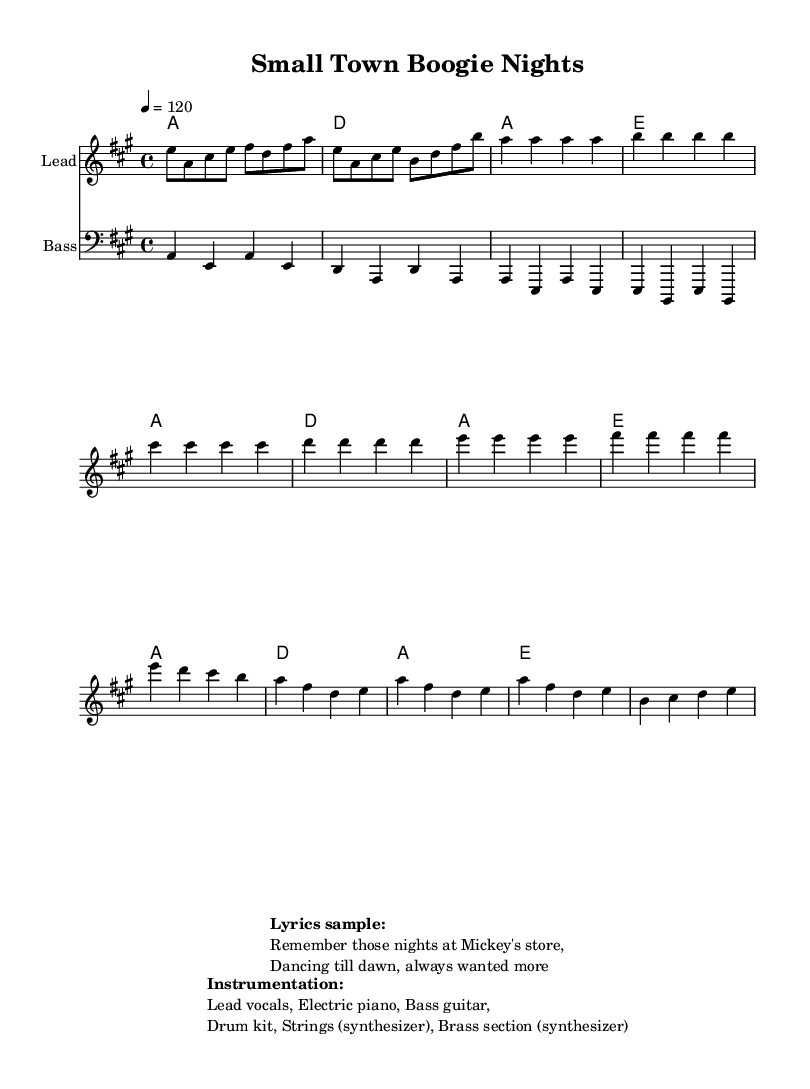What is the key signature of this music? The key signature indicated on the sheet music is A major, which has three sharps (F#, C#, and G#). This is visually confirmed by looking at the key signature placement at the beginning of the staff.
Answer: A major What is the time signature of the piece? The time signature shown in the sheet music is 4/4, meaning there are four beats in each measure and each quarter note gets one beat. This can be identified by the time signature notation at the beginning of the score.
Answer: 4/4 What is the tempo marking of the music? The tempo marking is specified as quarter note = 120, which indicates the speed of the piece. This can be seen prominently at the beginning of the sheet music.
Answer: 120 What instruments are featured in this arrangement? The instruments specified in the instrumentation section of the sheet music are lead vocals, electric piano, bass guitar, drum kit, strings (synthesizer), and brass section (synthesizer). This information is found in the markup directly below the score.
Answer: Lead vocals, Electric piano, Bass guitar, Drum kit, Strings (synthesizer), Brass section (synthesizer) How many measures are in the chorus section? The chorus consists of four measures, detailed in the melody section of the sheet music. By counting the measure lines in the chorus portion, we confirm it has a total of four measures.
Answer: 4 What rhythmic feel is commonly associated with Disco music found in this sheet? The piece maintains a steady four-on-the-floor beat typical of disco music, which is characterized by a strong bass drum hitting on each beat. This style is a defining aspect of disco music, evident in the bass line and overall structure.
Answer: Four-on-the-floor 